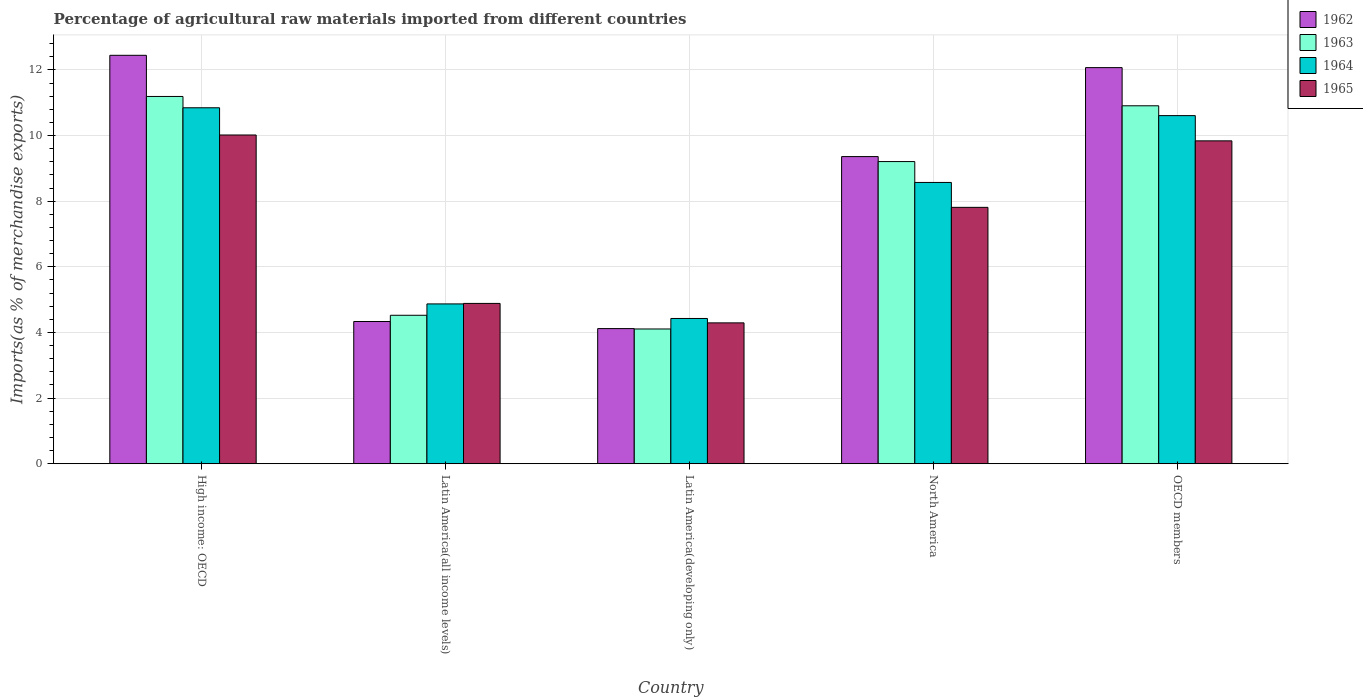How many groups of bars are there?
Give a very brief answer. 5. Are the number of bars per tick equal to the number of legend labels?
Make the answer very short. Yes. How many bars are there on the 3rd tick from the left?
Ensure brevity in your answer.  4. How many bars are there on the 2nd tick from the right?
Your answer should be compact. 4. What is the label of the 5th group of bars from the left?
Your response must be concise. OECD members. In how many cases, is the number of bars for a given country not equal to the number of legend labels?
Provide a short and direct response. 0. What is the percentage of imports to different countries in 1964 in North America?
Provide a succinct answer. 8.57. Across all countries, what is the maximum percentage of imports to different countries in 1963?
Provide a succinct answer. 11.19. Across all countries, what is the minimum percentage of imports to different countries in 1964?
Ensure brevity in your answer.  4.43. In which country was the percentage of imports to different countries in 1965 maximum?
Provide a succinct answer. High income: OECD. In which country was the percentage of imports to different countries in 1963 minimum?
Make the answer very short. Latin America(developing only). What is the total percentage of imports to different countries in 1964 in the graph?
Provide a short and direct response. 39.32. What is the difference between the percentage of imports to different countries in 1964 in Latin America(all income levels) and that in Latin America(developing only)?
Your answer should be compact. 0.44. What is the difference between the percentage of imports to different countries in 1962 in Latin America(all income levels) and the percentage of imports to different countries in 1965 in High income: OECD?
Make the answer very short. -5.68. What is the average percentage of imports to different countries in 1963 per country?
Provide a succinct answer. 7.99. What is the difference between the percentage of imports to different countries of/in 1964 and percentage of imports to different countries of/in 1963 in Latin America(developing only)?
Make the answer very short. 0.32. What is the ratio of the percentage of imports to different countries in 1965 in High income: OECD to that in Latin America(all income levels)?
Make the answer very short. 2.05. Is the percentage of imports to different countries in 1963 in Latin America(developing only) less than that in OECD members?
Offer a very short reply. Yes. What is the difference between the highest and the second highest percentage of imports to different countries in 1965?
Provide a short and direct response. -0.18. What is the difference between the highest and the lowest percentage of imports to different countries in 1964?
Make the answer very short. 6.42. Is the sum of the percentage of imports to different countries in 1964 in Latin America(all income levels) and Latin America(developing only) greater than the maximum percentage of imports to different countries in 1965 across all countries?
Keep it short and to the point. No. Is it the case that in every country, the sum of the percentage of imports to different countries in 1962 and percentage of imports to different countries in 1963 is greater than the sum of percentage of imports to different countries in 1964 and percentage of imports to different countries in 1965?
Your response must be concise. No. What does the 3rd bar from the left in OECD members represents?
Your response must be concise. 1964. How many bars are there?
Keep it short and to the point. 20. Are all the bars in the graph horizontal?
Offer a terse response. No. Does the graph contain any zero values?
Keep it short and to the point. No. Does the graph contain grids?
Your response must be concise. Yes. Where does the legend appear in the graph?
Provide a short and direct response. Top right. How many legend labels are there?
Provide a short and direct response. 4. How are the legend labels stacked?
Provide a short and direct response. Vertical. What is the title of the graph?
Offer a very short reply. Percentage of agricultural raw materials imported from different countries. What is the label or title of the Y-axis?
Provide a succinct answer. Imports(as % of merchandise exports). What is the Imports(as % of merchandise exports) of 1962 in High income: OECD?
Provide a short and direct response. 12.45. What is the Imports(as % of merchandise exports) in 1963 in High income: OECD?
Give a very brief answer. 11.19. What is the Imports(as % of merchandise exports) of 1964 in High income: OECD?
Make the answer very short. 10.85. What is the Imports(as % of merchandise exports) in 1965 in High income: OECD?
Your response must be concise. 10.02. What is the Imports(as % of merchandise exports) of 1962 in Latin America(all income levels)?
Provide a succinct answer. 4.33. What is the Imports(as % of merchandise exports) in 1963 in Latin America(all income levels)?
Provide a succinct answer. 4.52. What is the Imports(as % of merchandise exports) in 1964 in Latin America(all income levels)?
Provide a succinct answer. 4.87. What is the Imports(as % of merchandise exports) of 1965 in Latin America(all income levels)?
Your response must be concise. 4.89. What is the Imports(as % of merchandise exports) of 1962 in Latin America(developing only)?
Ensure brevity in your answer.  4.12. What is the Imports(as % of merchandise exports) of 1963 in Latin America(developing only)?
Offer a terse response. 4.11. What is the Imports(as % of merchandise exports) in 1964 in Latin America(developing only)?
Offer a very short reply. 4.43. What is the Imports(as % of merchandise exports) in 1965 in Latin America(developing only)?
Make the answer very short. 4.29. What is the Imports(as % of merchandise exports) in 1962 in North America?
Offer a very short reply. 9.36. What is the Imports(as % of merchandise exports) in 1963 in North America?
Provide a succinct answer. 9.21. What is the Imports(as % of merchandise exports) of 1964 in North America?
Your response must be concise. 8.57. What is the Imports(as % of merchandise exports) of 1965 in North America?
Provide a succinct answer. 7.81. What is the Imports(as % of merchandise exports) of 1962 in OECD members?
Keep it short and to the point. 12.07. What is the Imports(as % of merchandise exports) of 1963 in OECD members?
Make the answer very short. 10.91. What is the Imports(as % of merchandise exports) of 1964 in OECD members?
Offer a very short reply. 10.61. What is the Imports(as % of merchandise exports) in 1965 in OECD members?
Your answer should be compact. 9.84. Across all countries, what is the maximum Imports(as % of merchandise exports) in 1962?
Offer a terse response. 12.45. Across all countries, what is the maximum Imports(as % of merchandise exports) in 1963?
Your answer should be compact. 11.19. Across all countries, what is the maximum Imports(as % of merchandise exports) in 1964?
Provide a succinct answer. 10.85. Across all countries, what is the maximum Imports(as % of merchandise exports) in 1965?
Offer a very short reply. 10.02. Across all countries, what is the minimum Imports(as % of merchandise exports) in 1962?
Provide a succinct answer. 4.12. Across all countries, what is the minimum Imports(as % of merchandise exports) of 1963?
Keep it short and to the point. 4.11. Across all countries, what is the minimum Imports(as % of merchandise exports) in 1964?
Provide a succinct answer. 4.43. Across all countries, what is the minimum Imports(as % of merchandise exports) of 1965?
Make the answer very short. 4.29. What is the total Imports(as % of merchandise exports) of 1962 in the graph?
Give a very brief answer. 42.33. What is the total Imports(as % of merchandise exports) of 1963 in the graph?
Your answer should be very brief. 39.94. What is the total Imports(as % of merchandise exports) of 1964 in the graph?
Provide a succinct answer. 39.32. What is the total Imports(as % of merchandise exports) of 1965 in the graph?
Give a very brief answer. 36.85. What is the difference between the Imports(as % of merchandise exports) in 1962 in High income: OECD and that in Latin America(all income levels)?
Provide a short and direct response. 8.11. What is the difference between the Imports(as % of merchandise exports) of 1963 in High income: OECD and that in Latin America(all income levels)?
Your response must be concise. 6.67. What is the difference between the Imports(as % of merchandise exports) in 1964 in High income: OECD and that in Latin America(all income levels)?
Your answer should be compact. 5.98. What is the difference between the Imports(as % of merchandise exports) of 1965 in High income: OECD and that in Latin America(all income levels)?
Offer a very short reply. 5.13. What is the difference between the Imports(as % of merchandise exports) in 1962 in High income: OECD and that in Latin America(developing only)?
Keep it short and to the point. 8.33. What is the difference between the Imports(as % of merchandise exports) in 1963 in High income: OECD and that in Latin America(developing only)?
Keep it short and to the point. 7.09. What is the difference between the Imports(as % of merchandise exports) in 1964 in High income: OECD and that in Latin America(developing only)?
Give a very brief answer. 6.42. What is the difference between the Imports(as % of merchandise exports) of 1965 in High income: OECD and that in Latin America(developing only)?
Make the answer very short. 5.73. What is the difference between the Imports(as % of merchandise exports) of 1962 in High income: OECD and that in North America?
Your answer should be compact. 3.09. What is the difference between the Imports(as % of merchandise exports) in 1963 in High income: OECD and that in North America?
Offer a terse response. 1.98. What is the difference between the Imports(as % of merchandise exports) in 1964 in High income: OECD and that in North America?
Provide a short and direct response. 2.28. What is the difference between the Imports(as % of merchandise exports) in 1965 in High income: OECD and that in North America?
Offer a very short reply. 2.21. What is the difference between the Imports(as % of merchandise exports) in 1962 in High income: OECD and that in OECD members?
Your answer should be very brief. 0.38. What is the difference between the Imports(as % of merchandise exports) of 1963 in High income: OECD and that in OECD members?
Offer a terse response. 0.28. What is the difference between the Imports(as % of merchandise exports) of 1964 in High income: OECD and that in OECD members?
Your answer should be very brief. 0.24. What is the difference between the Imports(as % of merchandise exports) in 1965 in High income: OECD and that in OECD members?
Give a very brief answer. 0.18. What is the difference between the Imports(as % of merchandise exports) of 1962 in Latin America(all income levels) and that in Latin America(developing only)?
Give a very brief answer. 0.22. What is the difference between the Imports(as % of merchandise exports) of 1963 in Latin America(all income levels) and that in Latin America(developing only)?
Provide a succinct answer. 0.42. What is the difference between the Imports(as % of merchandise exports) in 1964 in Latin America(all income levels) and that in Latin America(developing only)?
Ensure brevity in your answer.  0.44. What is the difference between the Imports(as % of merchandise exports) in 1965 in Latin America(all income levels) and that in Latin America(developing only)?
Make the answer very short. 0.59. What is the difference between the Imports(as % of merchandise exports) of 1962 in Latin America(all income levels) and that in North America?
Keep it short and to the point. -5.03. What is the difference between the Imports(as % of merchandise exports) in 1963 in Latin America(all income levels) and that in North America?
Keep it short and to the point. -4.68. What is the difference between the Imports(as % of merchandise exports) in 1964 in Latin America(all income levels) and that in North America?
Offer a very short reply. -3.7. What is the difference between the Imports(as % of merchandise exports) of 1965 in Latin America(all income levels) and that in North America?
Ensure brevity in your answer.  -2.93. What is the difference between the Imports(as % of merchandise exports) of 1962 in Latin America(all income levels) and that in OECD members?
Your answer should be compact. -7.74. What is the difference between the Imports(as % of merchandise exports) in 1963 in Latin America(all income levels) and that in OECD members?
Your answer should be compact. -6.38. What is the difference between the Imports(as % of merchandise exports) in 1964 in Latin America(all income levels) and that in OECD members?
Make the answer very short. -5.74. What is the difference between the Imports(as % of merchandise exports) of 1965 in Latin America(all income levels) and that in OECD members?
Ensure brevity in your answer.  -4.95. What is the difference between the Imports(as % of merchandise exports) of 1962 in Latin America(developing only) and that in North America?
Your answer should be compact. -5.24. What is the difference between the Imports(as % of merchandise exports) in 1963 in Latin America(developing only) and that in North America?
Provide a short and direct response. -5.1. What is the difference between the Imports(as % of merchandise exports) in 1964 in Latin America(developing only) and that in North America?
Make the answer very short. -4.15. What is the difference between the Imports(as % of merchandise exports) in 1965 in Latin America(developing only) and that in North America?
Offer a very short reply. -3.52. What is the difference between the Imports(as % of merchandise exports) of 1962 in Latin America(developing only) and that in OECD members?
Your answer should be compact. -7.95. What is the difference between the Imports(as % of merchandise exports) in 1963 in Latin America(developing only) and that in OECD members?
Offer a terse response. -6.8. What is the difference between the Imports(as % of merchandise exports) in 1964 in Latin America(developing only) and that in OECD members?
Offer a very short reply. -6.18. What is the difference between the Imports(as % of merchandise exports) in 1965 in Latin America(developing only) and that in OECD members?
Give a very brief answer. -5.55. What is the difference between the Imports(as % of merchandise exports) of 1962 in North America and that in OECD members?
Your answer should be very brief. -2.71. What is the difference between the Imports(as % of merchandise exports) of 1963 in North America and that in OECD members?
Your response must be concise. -1.7. What is the difference between the Imports(as % of merchandise exports) of 1964 in North America and that in OECD members?
Keep it short and to the point. -2.04. What is the difference between the Imports(as % of merchandise exports) of 1965 in North America and that in OECD members?
Offer a very short reply. -2.03. What is the difference between the Imports(as % of merchandise exports) of 1962 in High income: OECD and the Imports(as % of merchandise exports) of 1963 in Latin America(all income levels)?
Your answer should be compact. 7.92. What is the difference between the Imports(as % of merchandise exports) in 1962 in High income: OECD and the Imports(as % of merchandise exports) in 1964 in Latin America(all income levels)?
Ensure brevity in your answer.  7.58. What is the difference between the Imports(as % of merchandise exports) of 1962 in High income: OECD and the Imports(as % of merchandise exports) of 1965 in Latin America(all income levels)?
Provide a succinct answer. 7.56. What is the difference between the Imports(as % of merchandise exports) of 1963 in High income: OECD and the Imports(as % of merchandise exports) of 1964 in Latin America(all income levels)?
Your answer should be compact. 6.32. What is the difference between the Imports(as % of merchandise exports) of 1963 in High income: OECD and the Imports(as % of merchandise exports) of 1965 in Latin America(all income levels)?
Provide a short and direct response. 6.31. What is the difference between the Imports(as % of merchandise exports) in 1964 in High income: OECD and the Imports(as % of merchandise exports) in 1965 in Latin America(all income levels)?
Keep it short and to the point. 5.96. What is the difference between the Imports(as % of merchandise exports) of 1962 in High income: OECD and the Imports(as % of merchandise exports) of 1963 in Latin America(developing only)?
Your answer should be very brief. 8.34. What is the difference between the Imports(as % of merchandise exports) of 1962 in High income: OECD and the Imports(as % of merchandise exports) of 1964 in Latin America(developing only)?
Your answer should be very brief. 8.02. What is the difference between the Imports(as % of merchandise exports) of 1962 in High income: OECD and the Imports(as % of merchandise exports) of 1965 in Latin America(developing only)?
Keep it short and to the point. 8.15. What is the difference between the Imports(as % of merchandise exports) of 1963 in High income: OECD and the Imports(as % of merchandise exports) of 1964 in Latin America(developing only)?
Keep it short and to the point. 6.77. What is the difference between the Imports(as % of merchandise exports) in 1963 in High income: OECD and the Imports(as % of merchandise exports) in 1965 in Latin America(developing only)?
Your answer should be very brief. 6.9. What is the difference between the Imports(as % of merchandise exports) of 1964 in High income: OECD and the Imports(as % of merchandise exports) of 1965 in Latin America(developing only)?
Make the answer very short. 6.55. What is the difference between the Imports(as % of merchandise exports) of 1962 in High income: OECD and the Imports(as % of merchandise exports) of 1963 in North America?
Provide a succinct answer. 3.24. What is the difference between the Imports(as % of merchandise exports) in 1962 in High income: OECD and the Imports(as % of merchandise exports) in 1964 in North America?
Offer a terse response. 3.87. What is the difference between the Imports(as % of merchandise exports) of 1962 in High income: OECD and the Imports(as % of merchandise exports) of 1965 in North America?
Your answer should be compact. 4.63. What is the difference between the Imports(as % of merchandise exports) in 1963 in High income: OECD and the Imports(as % of merchandise exports) in 1964 in North America?
Provide a succinct answer. 2.62. What is the difference between the Imports(as % of merchandise exports) in 1963 in High income: OECD and the Imports(as % of merchandise exports) in 1965 in North America?
Provide a short and direct response. 3.38. What is the difference between the Imports(as % of merchandise exports) of 1964 in High income: OECD and the Imports(as % of merchandise exports) of 1965 in North America?
Provide a succinct answer. 3.03. What is the difference between the Imports(as % of merchandise exports) of 1962 in High income: OECD and the Imports(as % of merchandise exports) of 1963 in OECD members?
Make the answer very short. 1.54. What is the difference between the Imports(as % of merchandise exports) of 1962 in High income: OECD and the Imports(as % of merchandise exports) of 1964 in OECD members?
Provide a short and direct response. 1.84. What is the difference between the Imports(as % of merchandise exports) in 1962 in High income: OECD and the Imports(as % of merchandise exports) in 1965 in OECD members?
Your answer should be compact. 2.61. What is the difference between the Imports(as % of merchandise exports) in 1963 in High income: OECD and the Imports(as % of merchandise exports) in 1964 in OECD members?
Make the answer very short. 0.58. What is the difference between the Imports(as % of merchandise exports) in 1963 in High income: OECD and the Imports(as % of merchandise exports) in 1965 in OECD members?
Your answer should be compact. 1.35. What is the difference between the Imports(as % of merchandise exports) in 1964 in High income: OECD and the Imports(as % of merchandise exports) in 1965 in OECD members?
Your answer should be compact. 1.01. What is the difference between the Imports(as % of merchandise exports) in 1962 in Latin America(all income levels) and the Imports(as % of merchandise exports) in 1963 in Latin America(developing only)?
Your response must be concise. 0.23. What is the difference between the Imports(as % of merchandise exports) of 1962 in Latin America(all income levels) and the Imports(as % of merchandise exports) of 1964 in Latin America(developing only)?
Ensure brevity in your answer.  -0.09. What is the difference between the Imports(as % of merchandise exports) of 1962 in Latin America(all income levels) and the Imports(as % of merchandise exports) of 1965 in Latin America(developing only)?
Your response must be concise. 0.04. What is the difference between the Imports(as % of merchandise exports) of 1963 in Latin America(all income levels) and the Imports(as % of merchandise exports) of 1964 in Latin America(developing only)?
Provide a succinct answer. 0.1. What is the difference between the Imports(as % of merchandise exports) in 1963 in Latin America(all income levels) and the Imports(as % of merchandise exports) in 1965 in Latin America(developing only)?
Your answer should be compact. 0.23. What is the difference between the Imports(as % of merchandise exports) in 1964 in Latin America(all income levels) and the Imports(as % of merchandise exports) in 1965 in Latin America(developing only)?
Your response must be concise. 0.58. What is the difference between the Imports(as % of merchandise exports) in 1962 in Latin America(all income levels) and the Imports(as % of merchandise exports) in 1963 in North America?
Give a very brief answer. -4.87. What is the difference between the Imports(as % of merchandise exports) of 1962 in Latin America(all income levels) and the Imports(as % of merchandise exports) of 1964 in North America?
Offer a very short reply. -4.24. What is the difference between the Imports(as % of merchandise exports) of 1962 in Latin America(all income levels) and the Imports(as % of merchandise exports) of 1965 in North America?
Offer a terse response. -3.48. What is the difference between the Imports(as % of merchandise exports) of 1963 in Latin America(all income levels) and the Imports(as % of merchandise exports) of 1964 in North America?
Offer a very short reply. -4.05. What is the difference between the Imports(as % of merchandise exports) in 1963 in Latin America(all income levels) and the Imports(as % of merchandise exports) in 1965 in North America?
Offer a terse response. -3.29. What is the difference between the Imports(as % of merchandise exports) in 1964 in Latin America(all income levels) and the Imports(as % of merchandise exports) in 1965 in North America?
Make the answer very short. -2.94. What is the difference between the Imports(as % of merchandise exports) of 1962 in Latin America(all income levels) and the Imports(as % of merchandise exports) of 1963 in OECD members?
Keep it short and to the point. -6.57. What is the difference between the Imports(as % of merchandise exports) of 1962 in Latin America(all income levels) and the Imports(as % of merchandise exports) of 1964 in OECD members?
Your response must be concise. -6.27. What is the difference between the Imports(as % of merchandise exports) in 1962 in Latin America(all income levels) and the Imports(as % of merchandise exports) in 1965 in OECD members?
Provide a short and direct response. -5.51. What is the difference between the Imports(as % of merchandise exports) in 1963 in Latin America(all income levels) and the Imports(as % of merchandise exports) in 1964 in OECD members?
Make the answer very short. -6.08. What is the difference between the Imports(as % of merchandise exports) in 1963 in Latin America(all income levels) and the Imports(as % of merchandise exports) in 1965 in OECD members?
Give a very brief answer. -5.32. What is the difference between the Imports(as % of merchandise exports) of 1964 in Latin America(all income levels) and the Imports(as % of merchandise exports) of 1965 in OECD members?
Your response must be concise. -4.97. What is the difference between the Imports(as % of merchandise exports) in 1962 in Latin America(developing only) and the Imports(as % of merchandise exports) in 1963 in North America?
Your answer should be compact. -5.09. What is the difference between the Imports(as % of merchandise exports) in 1962 in Latin America(developing only) and the Imports(as % of merchandise exports) in 1964 in North America?
Your response must be concise. -4.45. What is the difference between the Imports(as % of merchandise exports) in 1962 in Latin America(developing only) and the Imports(as % of merchandise exports) in 1965 in North America?
Make the answer very short. -3.69. What is the difference between the Imports(as % of merchandise exports) of 1963 in Latin America(developing only) and the Imports(as % of merchandise exports) of 1964 in North America?
Your response must be concise. -4.47. What is the difference between the Imports(as % of merchandise exports) in 1963 in Latin America(developing only) and the Imports(as % of merchandise exports) in 1965 in North America?
Your response must be concise. -3.71. What is the difference between the Imports(as % of merchandise exports) in 1964 in Latin America(developing only) and the Imports(as % of merchandise exports) in 1965 in North America?
Keep it short and to the point. -3.39. What is the difference between the Imports(as % of merchandise exports) of 1962 in Latin America(developing only) and the Imports(as % of merchandise exports) of 1963 in OECD members?
Make the answer very short. -6.79. What is the difference between the Imports(as % of merchandise exports) of 1962 in Latin America(developing only) and the Imports(as % of merchandise exports) of 1964 in OECD members?
Offer a terse response. -6.49. What is the difference between the Imports(as % of merchandise exports) of 1962 in Latin America(developing only) and the Imports(as % of merchandise exports) of 1965 in OECD members?
Offer a very short reply. -5.72. What is the difference between the Imports(as % of merchandise exports) in 1963 in Latin America(developing only) and the Imports(as % of merchandise exports) in 1964 in OECD members?
Provide a short and direct response. -6.5. What is the difference between the Imports(as % of merchandise exports) in 1963 in Latin America(developing only) and the Imports(as % of merchandise exports) in 1965 in OECD members?
Provide a short and direct response. -5.73. What is the difference between the Imports(as % of merchandise exports) in 1964 in Latin America(developing only) and the Imports(as % of merchandise exports) in 1965 in OECD members?
Provide a succinct answer. -5.41. What is the difference between the Imports(as % of merchandise exports) in 1962 in North America and the Imports(as % of merchandise exports) in 1963 in OECD members?
Provide a short and direct response. -1.55. What is the difference between the Imports(as % of merchandise exports) of 1962 in North America and the Imports(as % of merchandise exports) of 1964 in OECD members?
Your answer should be very brief. -1.25. What is the difference between the Imports(as % of merchandise exports) of 1962 in North America and the Imports(as % of merchandise exports) of 1965 in OECD members?
Your answer should be very brief. -0.48. What is the difference between the Imports(as % of merchandise exports) of 1963 in North America and the Imports(as % of merchandise exports) of 1964 in OECD members?
Make the answer very short. -1.4. What is the difference between the Imports(as % of merchandise exports) of 1963 in North America and the Imports(as % of merchandise exports) of 1965 in OECD members?
Offer a very short reply. -0.63. What is the difference between the Imports(as % of merchandise exports) of 1964 in North America and the Imports(as % of merchandise exports) of 1965 in OECD members?
Keep it short and to the point. -1.27. What is the average Imports(as % of merchandise exports) in 1962 per country?
Your response must be concise. 8.47. What is the average Imports(as % of merchandise exports) of 1963 per country?
Your answer should be compact. 7.99. What is the average Imports(as % of merchandise exports) in 1964 per country?
Your response must be concise. 7.86. What is the average Imports(as % of merchandise exports) of 1965 per country?
Offer a terse response. 7.37. What is the difference between the Imports(as % of merchandise exports) in 1962 and Imports(as % of merchandise exports) in 1963 in High income: OECD?
Your answer should be very brief. 1.25. What is the difference between the Imports(as % of merchandise exports) in 1962 and Imports(as % of merchandise exports) in 1964 in High income: OECD?
Offer a very short reply. 1.6. What is the difference between the Imports(as % of merchandise exports) of 1962 and Imports(as % of merchandise exports) of 1965 in High income: OECD?
Ensure brevity in your answer.  2.43. What is the difference between the Imports(as % of merchandise exports) in 1963 and Imports(as % of merchandise exports) in 1964 in High income: OECD?
Provide a succinct answer. 0.34. What is the difference between the Imports(as % of merchandise exports) of 1963 and Imports(as % of merchandise exports) of 1965 in High income: OECD?
Provide a succinct answer. 1.17. What is the difference between the Imports(as % of merchandise exports) in 1964 and Imports(as % of merchandise exports) in 1965 in High income: OECD?
Your answer should be very brief. 0.83. What is the difference between the Imports(as % of merchandise exports) of 1962 and Imports(as % of merchandise exports) of 1963 in Latin America(all income levels)?
Keep it short and to the point. -0.19. What is the difference between the Imports(as % of merchandise exports) in 1962 and Imports(as % of merchandise exports) in 1964 in Latin America(all income levels)?
Offer a terse response. -0.54. What is the difference between the Imports(as % of merchandise exports) of 1962 and Imports(as % of merchandise exports) of 1965 in Latin America(all income levels)?
Your answer should be compact. -0.55. What is the difference between the Imports(as % of merchandise exports) of 1963 and Imports(as % of merchandise exports) of 1964 in Latin America(all income levels)?
Offer a very short reply. -0.35. What is the difference between the Imports(as % of merchandise exports) in 1963 and Imports(as % of merchandise exports) in 1965 in Latin America(all income levels)?
Keep it short and to the point. -0.36. What is the difference between the Imports(as % of merchandise exports) of 1964 and Imports(as % of merchandise exports) of 1965 in Latin America(all income levels)?
Offer a very short reply. -0.02. What is the difference between the Imports(as % of merchandise exports) of 1962 and Imports(as % of merchandise exports) of 1963 in Latin America(developing only)?
Your answer should be very brief. 0.01. What is the difference between the Imports(as % of merchandise exports) in 1962 and Imports(as % of merchandise exports) in 1964 in Latin America(developing only)?
Offer a very short reply. -0.31. What is the difference between the Imports(as % of merchandise exports) in 1962 and Imports(as % of merchandise exports) in 1965 in Latin America(developing only)?
Provide a short and direct response. -0.17. What is the difference between the Imports(as % of merchandise exports) of 1963 and Imports(as % of merchandise exports) of 1964 in Latin America(developing only)?
Offer a terse response. -0.32. What is the difference between the Imports(as % of merchandise exports) in 1963 and Imports(as % of merchandise exports) in 1965 in Latin America(developing only)?
Offer a terse response. -0.19. What is the difference between the Imports(as % of merchandise exports) of 1964 and Imports(as % of merchandise exports) of 1965 in Latin America(developing only)?
Give a very brief answer. 0.13. What is the difference between the Imports(as % of merchandise exports) of 1962 and Imports(as % of merchandise exports) of 1963 in North America?
Make the answer very short. 0.15. What is the difference between the Imports(as % of merchandise exports) in 1962 and Imports(as % of merchandise exports) in 1964 in North America?
Your response must be concise. 0.79. What is the difference between the Imports(as % of merchandise exports) of 1962 and Imports(as % of merchandise exports) of 1965 in North America?
Offer a terse response. 1.55. What is the difference between the Imports(as % of merchandise exports) of 1963 and Imports(as % of merchandise exports) of 1964 in North America?
Your answer should be compact. 0.64. What is the difference between the Imports(as % of merchandise exports) of 1963 and Imports(as % of merchandise exports) of 1965 in North America?
Your answer should be compact. 1.39. What is the difference between the Imports(as % of merchandise exports) in 1964 and Imports(as % of merchandise exports) in 1965 in North America?
Offer a very short reply. 0.76. What is the difference between the Imports(as % of merchandise exports) of 1962 and Imports(as % of merchandise exports) of 1963 in OECD members?
Ensure brevity in your answer.  1.16. What is the difference between the Imports(as % of merchandise exports) in 1962 and Imports(as % of merchandise exports) in 1964 in OECD members?
Offer a very short reply. 1.46. What is the difference between the Imports(as % of merchandise exports) of 1962 and Imports(as % of merchandise exports) of 1965 in OECD members?
Your answer should be very brief. 2.23. What is the difference between the Imports(as % of merchandise exports) of 1963 and Imports(as % of merchandise exports) of 1964 in OECD members?
Give a very brief answer. 0.3. What is the difference between the Imports(as % of merchandise exports) in 1963 and Imports(as % of merchandise exports) in 1965 in OECD members?
Keep it short and to the point. 1.07. What is the difference between the Imports(as % of merchandise exports) of 1964 and Imports(as % of merchandise exports) of 1965 in OECD members?
Your response must be concise. 0.77. What is the ratio of the Imports(as % of merchandise exports) of 1962 in High income: OECD to that in Latin America(all income levels)?
Provide a succinct answer. 2.87. What is the ratio of the Imports(as % of merchandise exports) of 1963 in High income: OECD to that in Latin America(all income levels)?
Your response must be concise. 2.47. What is the ratio of the Imports(as % of merchandise exports) in 1964 in High income: OECD to that in Latin America(all income levels)?
Offer a very short reply. 2.23. What is the ratio of the Imports(as % of merchandise exports) in 1965 in High income: OECD to that in Latin America(all income levels)?
Offer a very short reply. 2.05. What is the ratio of the Imports(as % of merchandise exports) in 1962 in High income: OECD to that in Latin America(developing only)?
Provide a short and direct response. 3.02. What is the ratio of the Imports(as % of merchandise exports) in 1963 in High income: OECD to that in Latin America(developing only)?
Keep it short and to the point. 2.73. What is the ratio of the Imports(as % of merchandise exports) of 1964 in High income: OECD to that in Latin America(developing only)?
Provide a short and direct response. 2.45. What is the ratio of the Imports(as % of merchandise exports) of 1965 in High income: OECD to that in Latin America(developing only)?
Your response must be concise. 2.33. What is the ratio of the Imports(as % of merchandise exports) in 1962 in High income: OECD to that in North America?
Keep it short and to the point. 1.33. What is the ratio of the Imports(as % of merchandise exports) in 1963 in High income: OECD to that in North America?
Ensure brevity in your answer.  1.22. What is the ratio of the Imports(as % of merchandise exports) in 1964 in High income: OECD to that in North America?
Your response must be concise. 1.27. What is the ratio of the Imports(as % of merchandise exports) in 1965 in High income: OECD to that in North America?
Your response must be concise. 1.28. What is the ratio of the Imports(as % of merchandise exports) of 1962 in High income: OECD to that in OECD members?
Provide a succinct answer. 1.03. What is the ratio of the Imports(as % of merchandise exports) in 1963 in High income: OECD to that in OECD members?
Provide a succinct answer. 1.03. What is the ratio of the Imports(as % of merchandise exports) of 1964 in High income: OECD to that in OECD members?
Your response must be concise. 1.02. What is the ratio of the Imports(as % of merchandise exports) of 1965 in High income: OECD to that in OECD members?
Your response must be concise. 1.02. What is the ratio of the Imports(as % of merchandise exports) in 1962 in Latin America(all income levels) to that in Latin America(developing only)?
Offer a very short reply. 1.05. What is the ratio of the Imports(as % of merchandise exports) in 1963 in Latin America(all income levels) to that in Latin America(developing only)?
Make the answer very short. 1.1. What is the ratio of the Imports(as % of merchandise exports) in 1964 in Latin America(all income levels) to that in Latin America(developing only)?
Ensure brevity in your answer.  1.1. What is the ratio of the Imports(as % of merchandise exports) of 1965 in Latin America(all income levels) to that in Latin America(developing only)?
Keep it short and to the point. 1.14. What is the ratio of the Imports(as % of merchandise exports) of 1962 in Latin America(all income levels) to that in North America?
Provide a succinct answer. 0.46. What is the ratio of the Imports(as % of merchandise exports) in 1963 in Latin America(all income levels) to that in North America?
Make the answer very short. 0.49. What is the ratio of the Imports(as % of merchandise exports) in 1964 in Latin America(all income levels) to that in North America?
Your answer should be very brief. 0.57. What is the ratio of the Imports(as % of merchandise exports) in 1965 in Latin America(all income levels) to that in North America?
Keep it short and to the point. 0.63. What is the ratio of the Imports(as % of merchandise exports) in 1962 in Latin America(all income levels) to that in OECD members?
Your answer should be very brief. 0.36. What is the ratio of the Imports(as % of merchandise exports) of 1963 in Latin America(all income levels) to that in OECD members?
Provide a succinct answer. 0.41. What is the ratio of the Imports(as % of merchandise exports) in 1964 in Latin America(all income levels) to that in OECD members?
Provide a succinct answer. 0.46. What is the ratio of the Imports(as % of merchandise exports) in 1965 in Latin America(all income levels) to that in OECD members?
Your answer should be very brief. 0.5. What is the ratio of the Imports(as % of merchandise exports) in 1962 in Latin America(developing only) to that in North America?
Give a very brief answer. 0.44. What is the ratio of the Imports(as % of merchandise exports) in 1963 in Latin America(developing only) to that in North America?
Your response must be concise. 0.45. What is the ratio of the Imports(as % of merchandise exports) of 1964 in Latin America(developing only) to that in North America?
Your response must be concise. 0.52. What is the ratio of the Imports(as % of merchandise exports) in 1965 in Latin America(developing only) to that in North America?
Your answer should be very brief. 0.55. What is the ratio of the Imports(as % of merchandise exports) in 1962 in Latin America(developing only) to that in OECD members?
Provide a succinct answer. 0.34. What is the ratio of the Imports(as % of merchandise exports) in 1963 in Latin America(developing only) to that in OECD members?
Your answer should be compact. 0.38. What is the ratio of the Imports(as % of merchandise exports) of 1964 in Latin America(developing only) to that in OECD members?
Make the answer very short. 0.42. What is the ratio of the Imports(as % of merchandise exports) of 1965 in Latin America(developing only) to that in OECD members?
Your answer should be compact. 0.44. What is the ratio of the Imports(as % of merchandise exports) of 1962 in North America to that in OECD members?
Offer a very short reply. 0.78. What is the ratio of the Imports(as % of merchandise exports) of 1963 in North America to that in OECD members?
Provide a short and direct response. 0.84. What is the ratio of the Imports(as % of merchandise exports) in 1964 in North America to that in OECD members?
Your response must be concise. 0.81. What is the ratio of the Imports(as % of merchandise exports) in 1965 in North America to that in OECD members?
Ensure brevity in your answer.  0.79. What is the difference between the highest and the second highest Imports(as % of merchandise exports) in 1962?
Your answer should be compact. 0.38. What is the difference between the highest and the second highest Imports(as % of merchandise exports) of 1963?
Provide a short and direct response. 0.28. What is the difference between the highest and the second highest Imports(as % of merchandise exports) in 1964?
Your answer should be compact. 0.24. What is the difference between the highest and the second highest Imports(as % of merchandise exports) in 1965?
Your answer should be compact. 0.18. What is the difference between the highest and the lowest Imports(as % of merchandise exports) of 1962?
Your answer should be compact. 8.33. What is the difference between the highest and the lowest Imports(as % of merchandise exports) in 1963?
Keep it short and to the point. 7.09. What is the difference between the highest and the lowest Imports(as % of merchandise exports) of 1964?
Offer a terse response. 6.42. What is the difference between the highest and the lowest Imports(as % of merchandise exports) of 1965?
Your response must be concise. 5.73. 